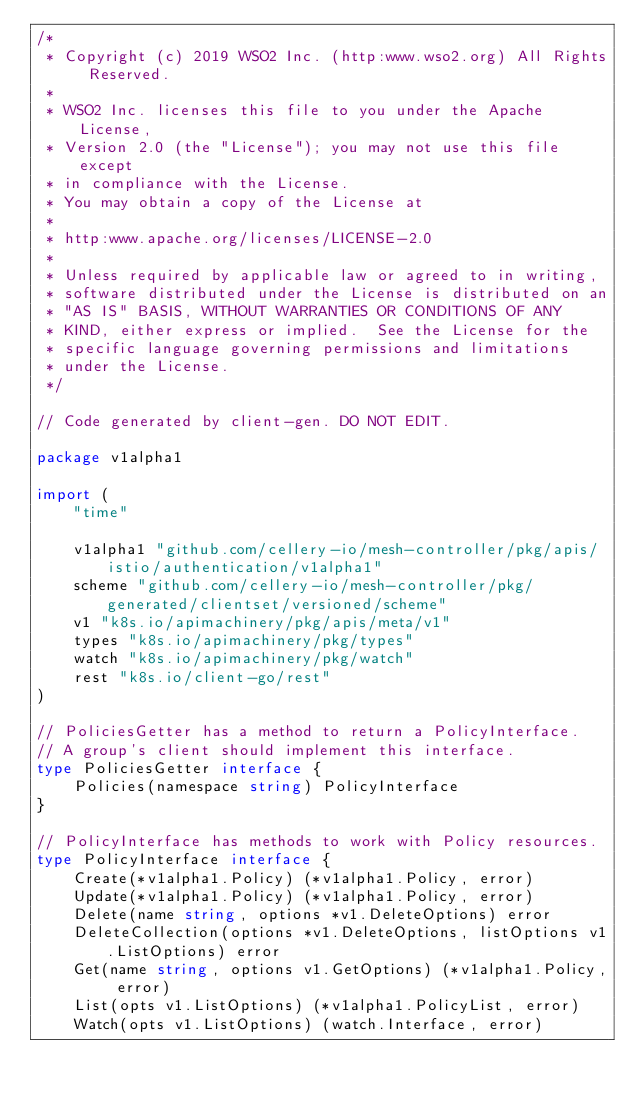Convert code to text. <code><loc_0><loc_0><loc_500><loc_500><_Go_>/*
 * Copyright (c) 2019 WSO2 Inc. (http:www.wso2.org) All Rights Reserved.
 *
 * WSO2 Inc. licenses this file to you under the Apache License,
 * Version 2.0 (the "License"); you may not use this file except
 * in compliance with the License.
 * You may obtain a copy of the License at
 *
 * http:www.apache.org/licenses/LICENSE-2.0
 *
 * Unless required by applicable law or agreed to in writing,
 * software distributed under the License is distributed on an
 * "AS IS" BASIS, WITHOUT WARRANTIES OR CONDITIONS OF ANY
 * KIND, either express or implied.  See the License for the
 * specific language governing permissions and limitations
 * under the License.
 */

// Code generated by client-gen. DO NOT EDIT.

package v1alpha1

import (
	"time"

	v1alpha1 "github.com/cellery-io/mesh-controller/pkg/apis/istio/authentication/v1alpha1"
	scheme "github.com/cellery-io/mesh-controller/pkg/generated/clientset/versioned/scheme"
	v1 "k8s.io/apimachinery/pkg/apis/meta/v1"
	types "k8s.io/apimachinery/pkg/types"
	watch "k8s.io/apimachinery/pkg/watch"
	rest "k8s.io/client-go/rest"
)

// PoliciesGetter has a method to return a PolicyInterface.
// A group's client should implement this interface.
type PoliciesGetter interface {
	Policies(namespace string) PolicyInterface
}

// PolicyInterface has methods to work with Policy resources.
type PolicyInterface interface {
	Create(*v1alpha1.Policy) (*v1alpha1.Policy, error)
	Update(*v1alpha1.Policy) (*v1alpha1.Policy, error)
	Delete(name string, options *v1.DeleteOptions) error
	DeleteCollection(options *v1.DeleteOptions, listOptions v1.ListOptions) error
	Get(name string, options v1.GetOptions) (*v1alpha1.Policy, error)
	List(opts v1.ListOptions) (*v1alpha1.PolicyList, error)
	Watch(opts v1.ListOptions) (watch.Interface, error)</code> 